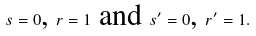<formula> <loc_0><loc_0><loc_500><loc_500>s = 0 \text {, } r = 1 \text { and } s ^ { \prime } = 0 \text {, } r ^ { \prime } = 1 .</formula> 